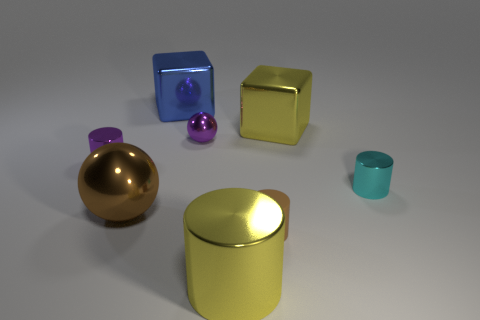There is a shiny block that is the same color as the large cylinder; what size is it?
Provide a short and direct response. Large. How many cubes are large objects or brown rubber things?
Provide a succinct answer. 2. There is a purple thing that is to the left of the blue metal cube; is it the same shape as the brown matte object?
Offer a terse response. Yes. Is the number of big blue shiny objects on the left side of the cyan thing greater than the number of tiny cyan rubber balls?
Provide a short and direct response. Yes. What color is the other rubber cylinder that is the same size as the purple cylinder?
Give a very brief answer. Brown. How many objects are small cylinders to the right of the purple cylinder or small cyan metallic blocks?
Ensure brevity in your answer.  2. There is a tiny thing that is the same color as the large ball; what shape is it?
Offer a very short reply. Cylinder. The yellow thing behind the shiny ball right of the large blue shiny cube is made of what material?
Your response must be concise. Metal. Are there any large spheres made of the same material as the tiny purple cylinder?
Provide a succinct answer. Yes. Are there any tiny cyan metal objects that are in front of the small metal cylinder that is behind the small cyan cylinder?
Your answer should be very brief. Yes. 